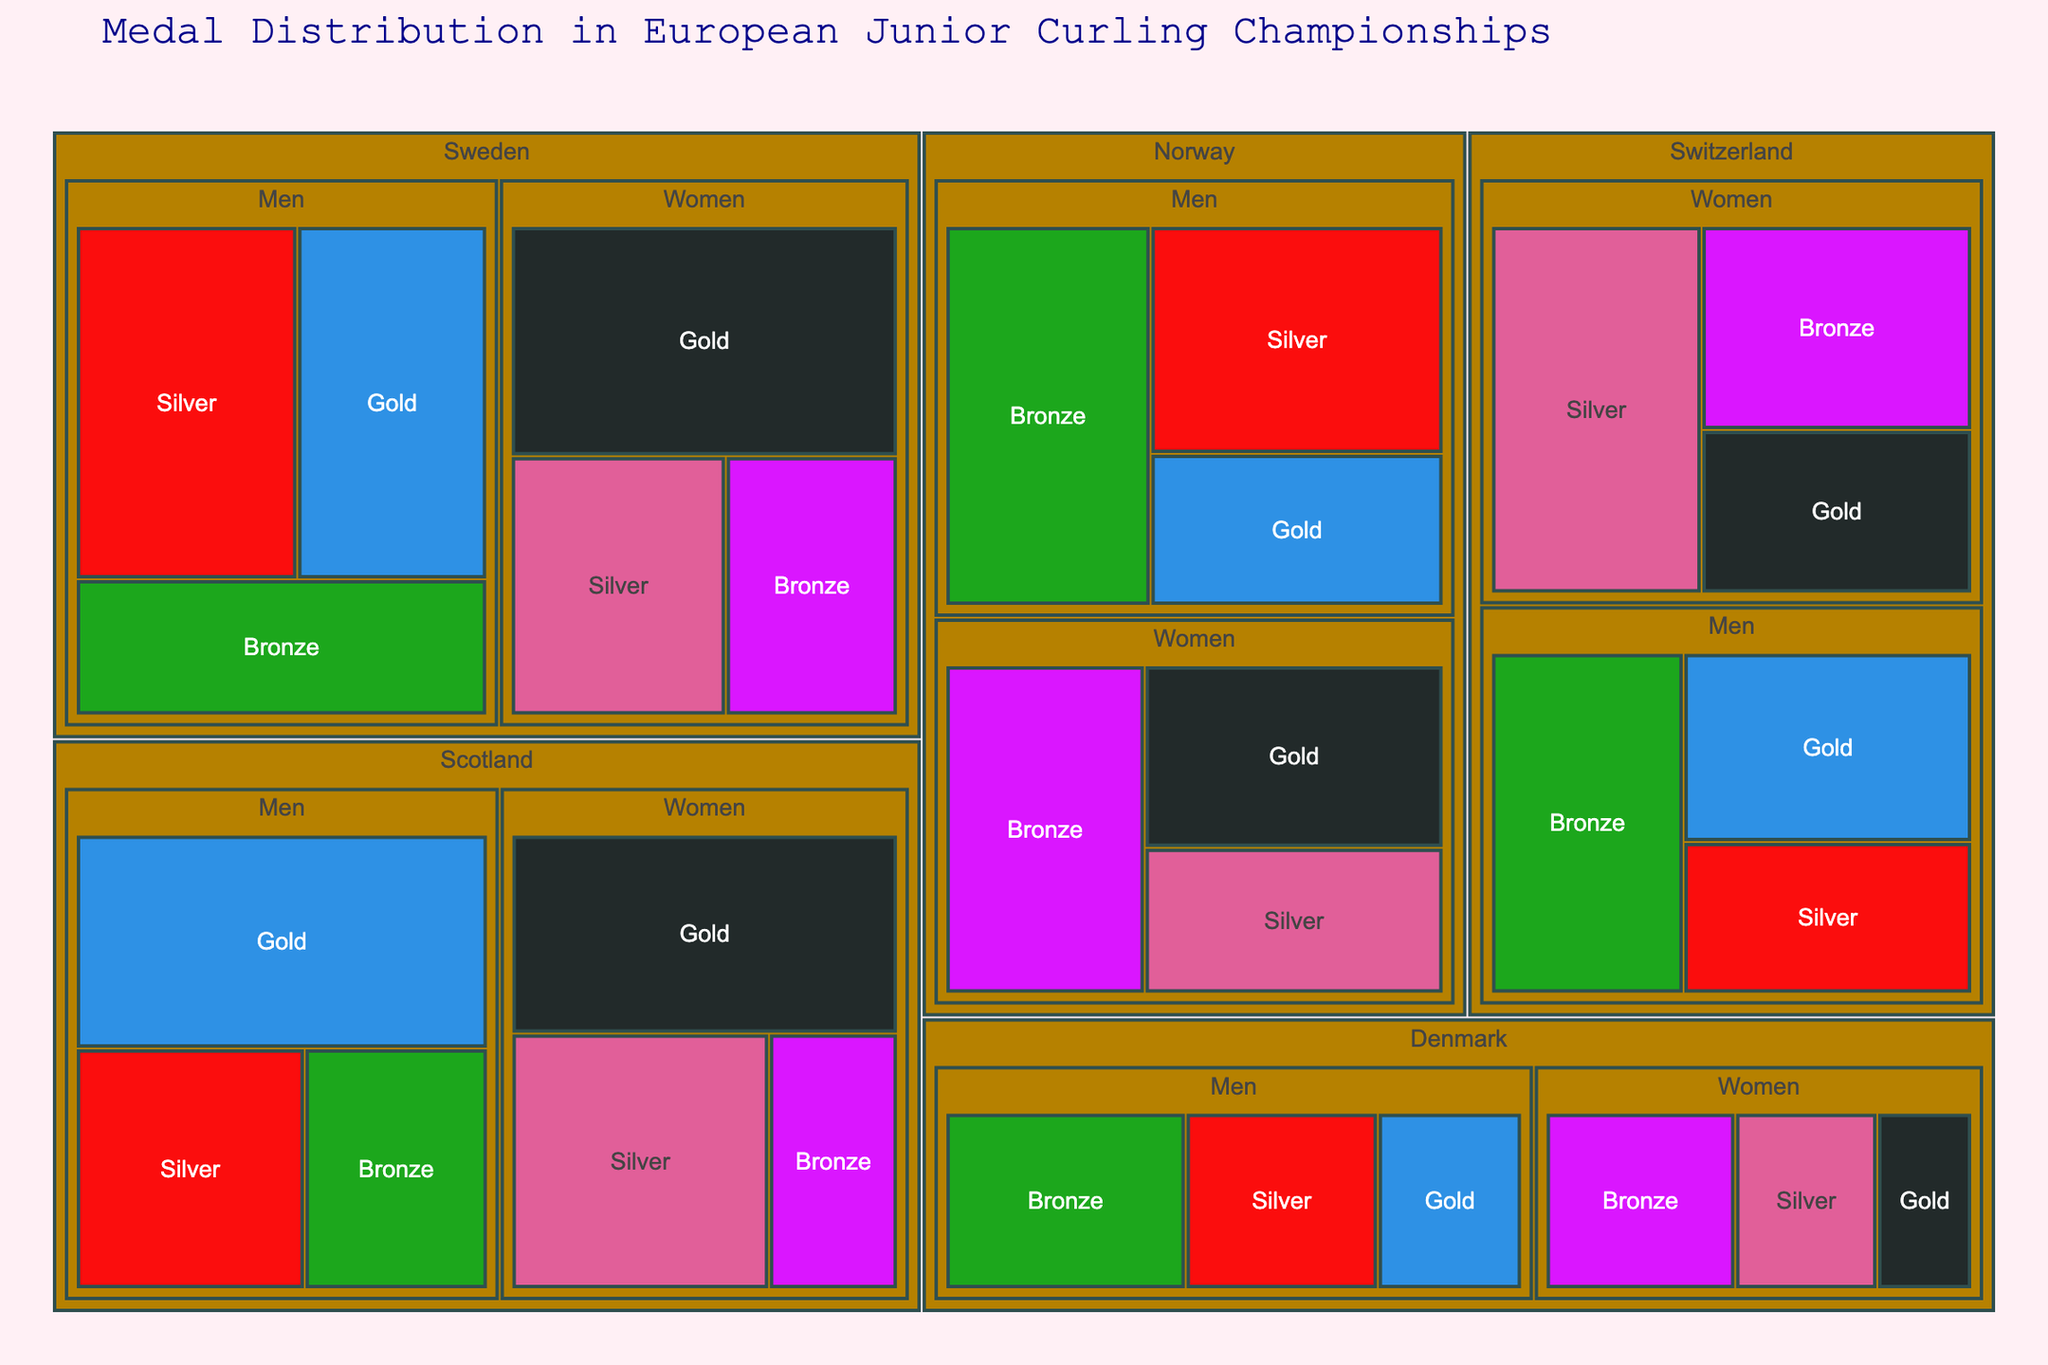What is the title of the Treemap? The title is usually at the top of the figure and provides a clear indication of what the data represents.
Answer: Medal Distribution in European Junior Curling Championships Which country earned the most gold medals in the Men’s category? By comparing the sizes of the gold medal sections within each country under the Men’s category, the country with the largest section will be evident.
Answer: Scotland How many silver medals have Swedish men and women won in total? Sum the silver medals for Swedish men and women by adding the men’s silver count and the women’s silver count. That is 7 + 5 = 12.
Answer: 12 Which country has the least number of total medals in the Women's category? Check the smallest section overall for the Women's category in the Treemap. Denmark shows the smallest combined size for Women.
Answer: Denmark How does the number of bronze medals won by Norwegian men compare to those won by Norwegian women? Compare the sizes of the bronze sections for Norwegian men and women. Norwegian men: 7, Norwegian women: 6.
Answer: Norwegian men have more bronze medals than Norwegian women What is the total number of medals won by Switzerland in the Men's category? Sum all the medals (gold, silver, bronze) for Swiss men: 5 + 4 + 6 = 15.
Answer: 15 Compare the total number of medals won by Scottish women to Swedish women. Sum all medal counts for each gender category separately: Scottish women (7+6+3 = 16) vs Swedish women (8+5+4 = 17).
Answer: Swedish women have more medals than Scottish women Which gender has won more medals for Norway, men or women? Add up the medal counts for each gender in Norway: Men (4+6+7) and Women (5+4+6). Compare the sums: 17 vs 15.
Answer: Men What is the combined number of gold medals won by Denmark? Sum all the gold medals won by Denmark in both categories: 3 (men) + 2 (women) = 5.
Answer: 5 Which country has the highest variety of medals in the Men’s category? Check the distribution and count of each type of medal (gold, silver, bronze) in the Men’s category for each country. If the distribution is not clear in terms of visual size, count them.
Answer: Norway (3 types) 